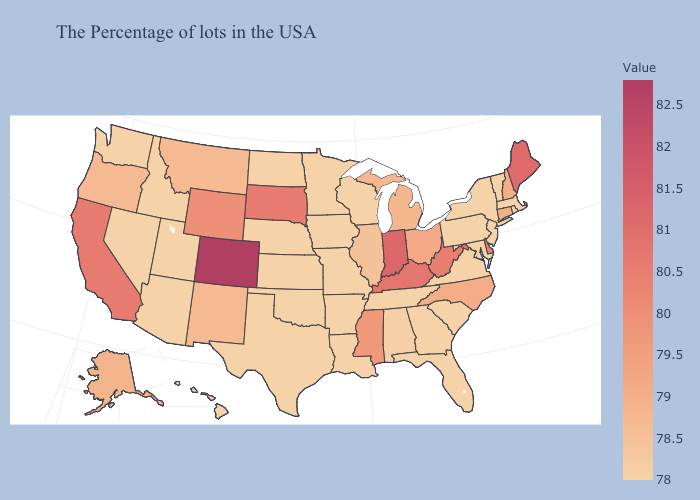Is the legend a continuous bar?
Concise answer only. Yes. Among the states that border Oklahoma , which have the lowest value?
Be succinct. Missouri, Arkansas, Kansas, Texas. Which states hav the highest value in the West?
Concise answer only. Colorado. Among the states that border Nebraska , does Iowa have the lowest value?
Answer briefly. Yes. Does North Carolina have a lower value than Arizona?
Short answer required. No. 